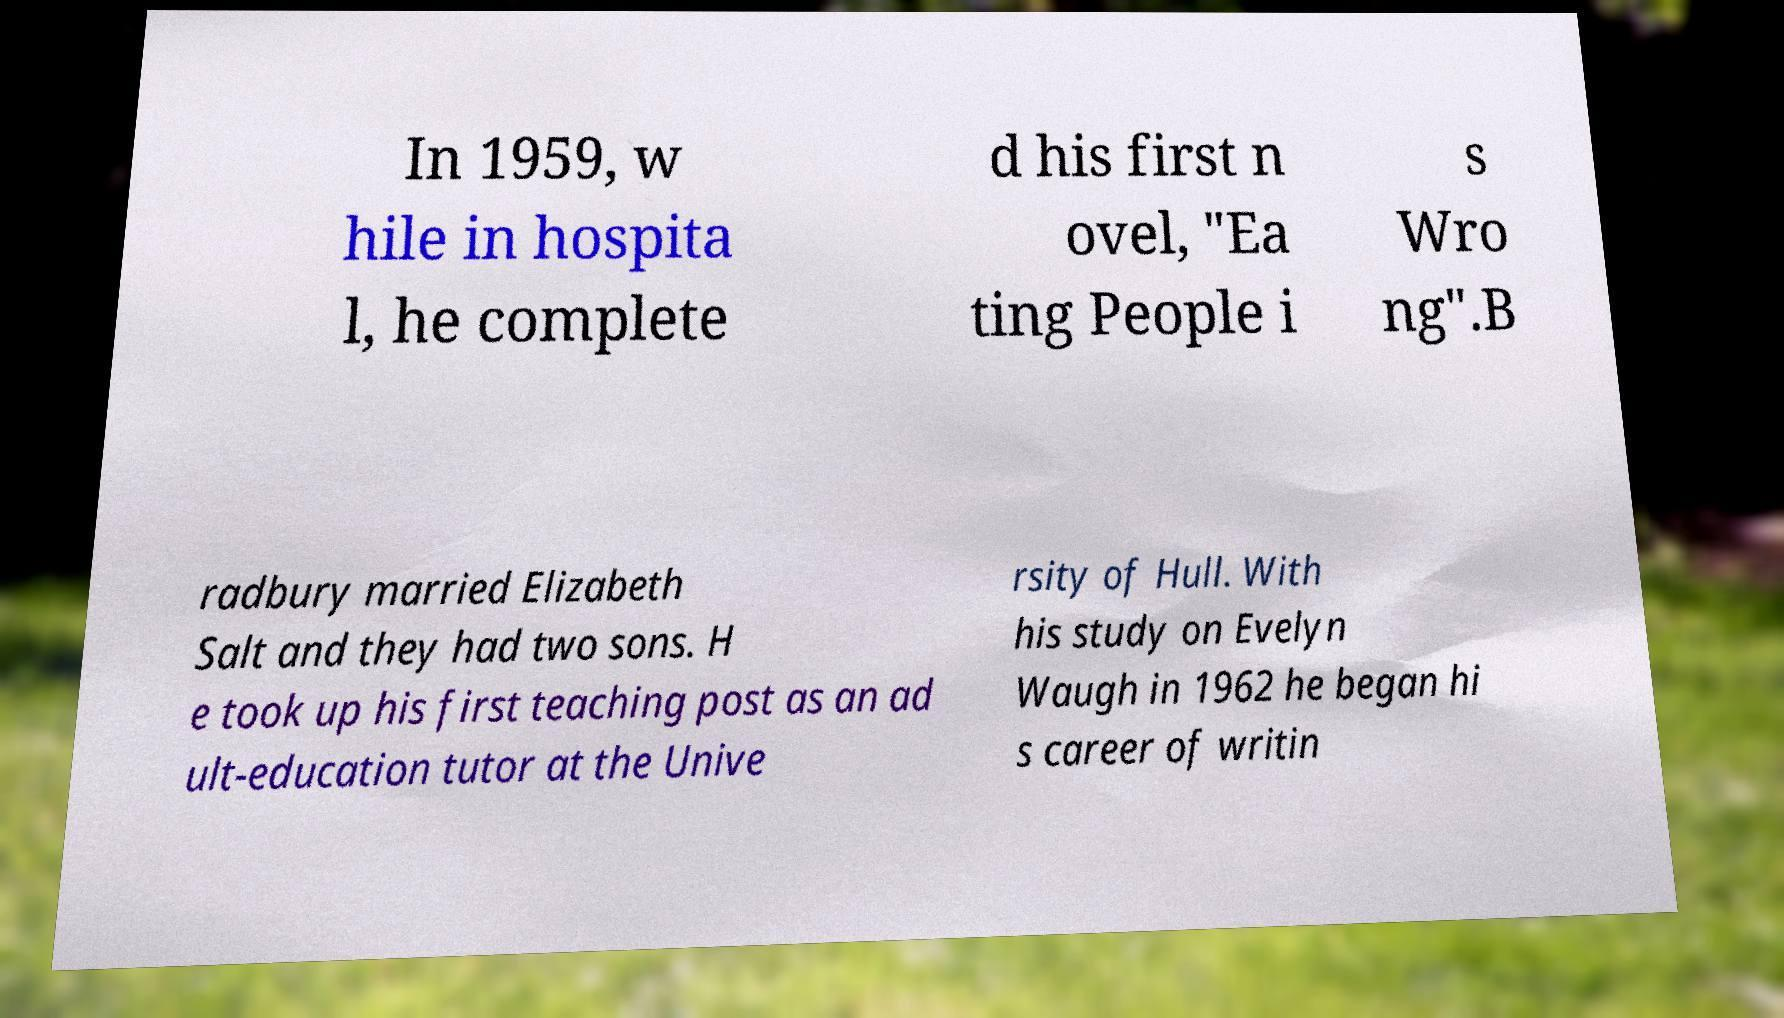Can you read and provide the text displayed in the image?This photo seems to have some interesting text. Can you extract and type it out for me? In 1959, w hile in hospita l, he complete d his first n ovel, "Ea ting People i s Wro ng".B radbury married Elizabeth Salt and they had two sons. H e took up his first teaching post as an ad ult-education tutor at the Unive rsity of Hull. With his study on Evelyn Waugh in 1962 he began hi s career of writin 